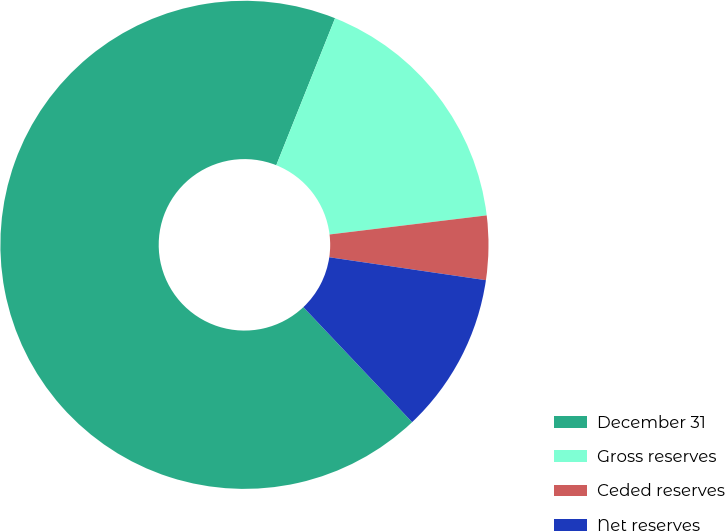Convert chart to OTSL. <chart><loc_0><loc_0><loc_500><loc_500><pie_chart><fcel>December 31<fcel>Gross reserves<fcel>Ceded reserves<fcel>Net reserves<nl><fcel>68.11%<fcel>17.02%<fcel>4.24%<fcel>10.63%<nl></chart> 